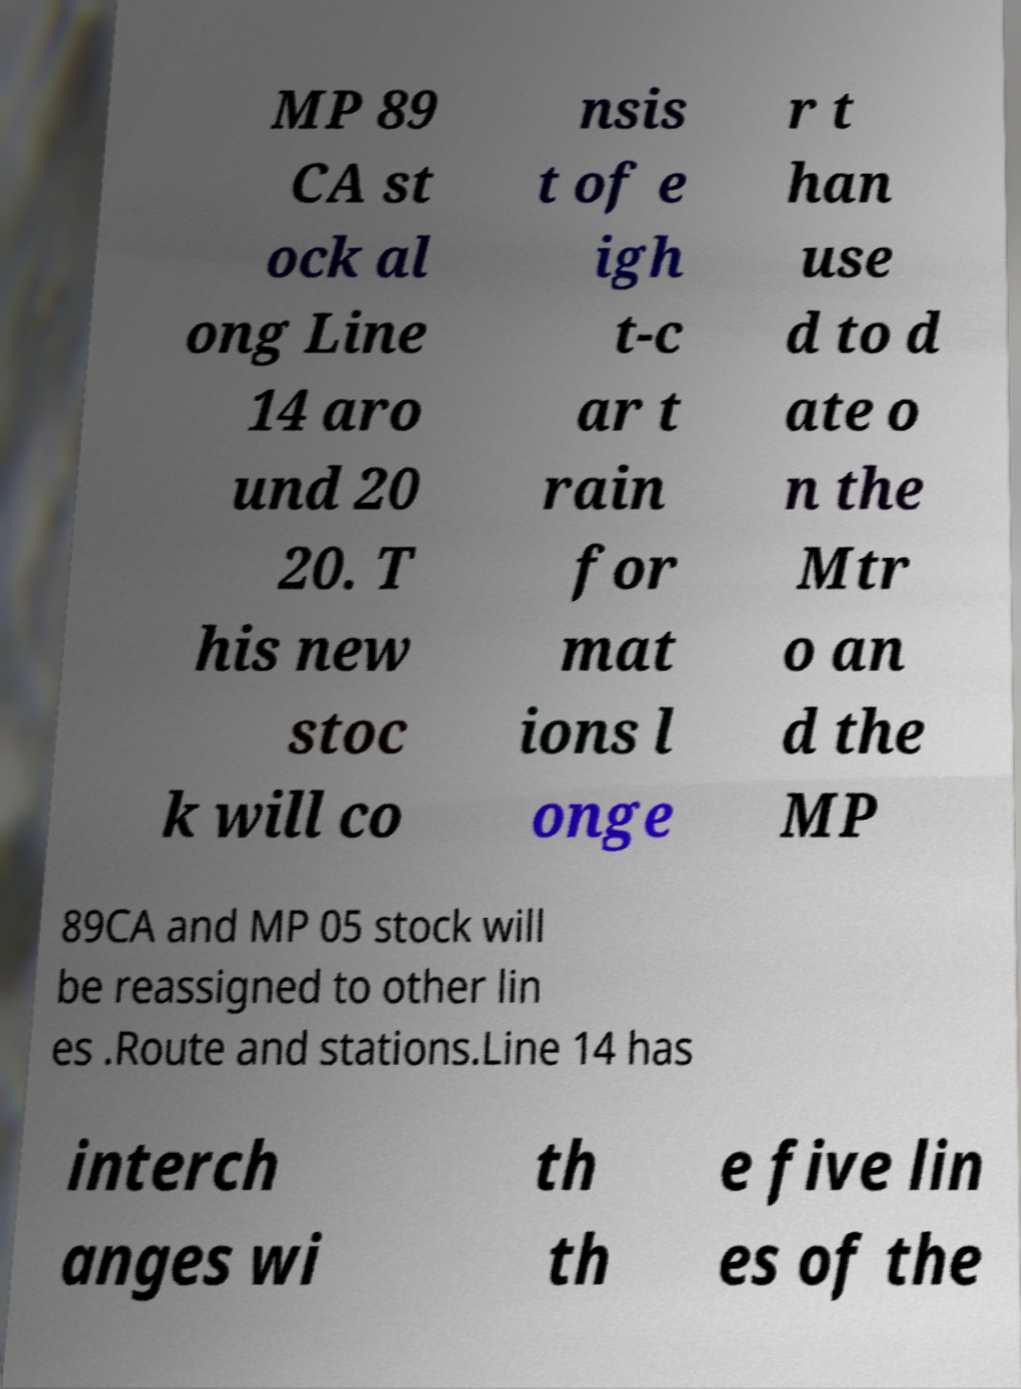Could you extract and type out the text from this image? MP 89 CA st ock al ong Line 14 aro und 20 20. T his new stoc k will co nsis t of e igh t-c ar t rain for mat ions l onge r t han use d to d ate o n the Mtr o an d the MP 89CA and MP 05 stock will be reassigned to other lin es .Route and stations.Line 14 has interch anges wi th th e five lin es of the 